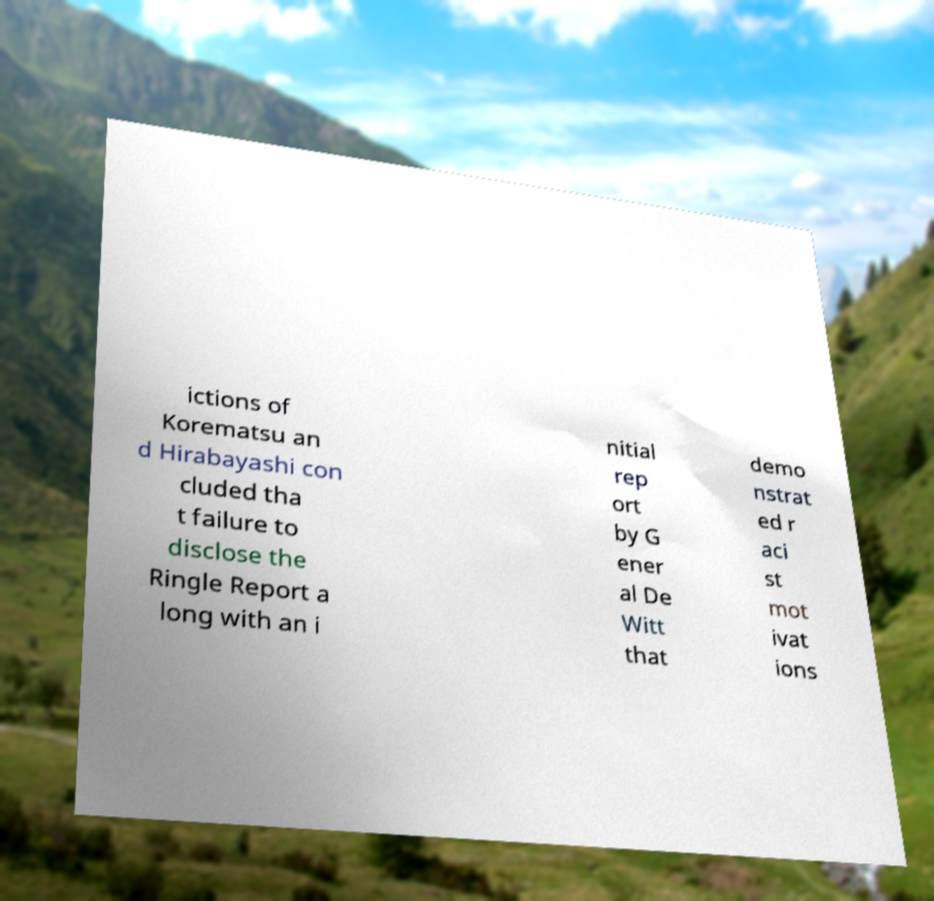Could you assist in decoding the text presented in this image and type it out clearly? ictions of Korematsu an d Hirabayashi con cluded tha t failure to disclose the Ringle Report a long with an i nitial rep ort by G ener al De Witt that demo nstrat ed r aci st mot ivat ions 